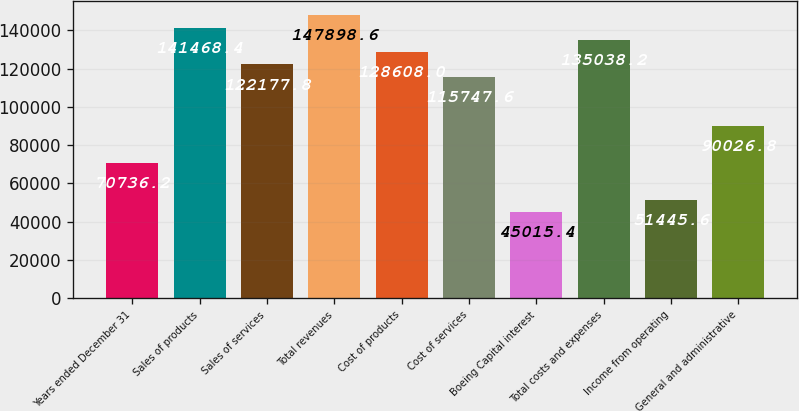Convert chart. <chart><loc_0><loc_0><loc_500><loc_500><bar_chart><fcel>Years ended December 31<fcel>Sales of products<fcel>Sales of services<fcel>Total revenues<fcel>Cost of products<fcel>Cost of services<fcel>Boeing Capital interest<fcel>Total costs and expenses<fcel>Income from operating<fcel>General and administrative<nl><fcel>70736.2<fcel>141468<fcel>122178<fcel>147899<fcel>128608<fcel>115748<fcel>45015.4<fcel>135038<fcel>51445.6<fcel>90026.8<nl></chart> 